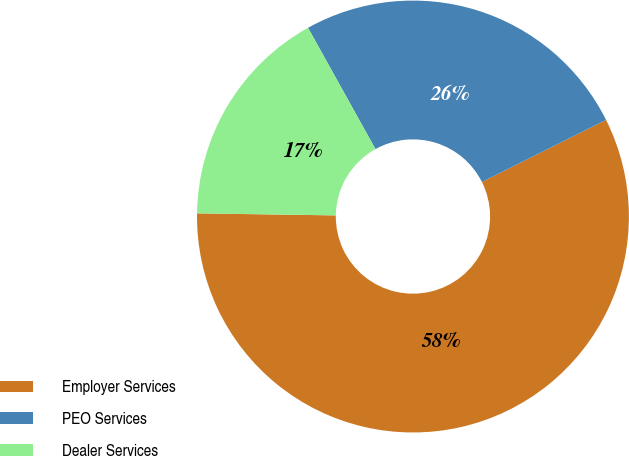Convert chart. <chart><loc_0><loc_0><loc_500><loc_500><pie_chart><fcel>Employer Services<fcel>PEO Services<fcel>Dealer Services<nl><fcel>57.62%<fcel>25.69%<fcel>16.69%<nl></chart> 